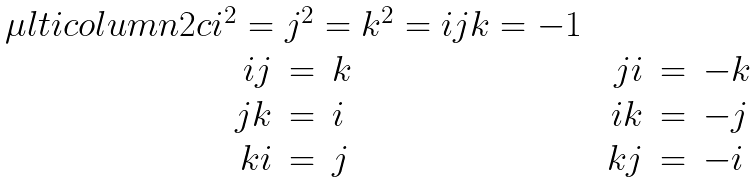<formula> <loc_0><loc_0><loc_500><loc_500>\begin{array} { c c } \mu l t i c o l u m n { 2 } { c } { i ^ { 2 } = j ^ { 2 } = k ^ { 2 } = i j k = - 1 } \\ \begin{array} { r c l } i j & = & k \\ j k & = & i \\ k i & = & j \end{array} & \begin{array} { r c l } j i & = & - k \\ i k & = & - j \\ k j & = & - i \end{array} \end{array}</formula> 